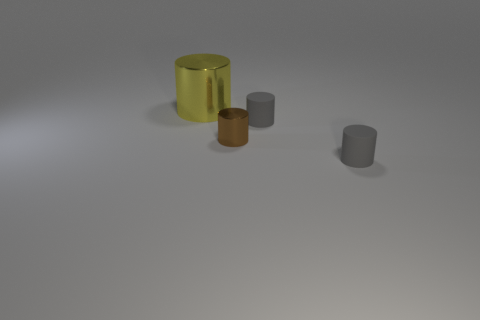Subtract all small cylinders. How many cylinders are left? 1 Add 3 small shiny objects. How many objects exist? 7 Subtract all brown cylinders. How many cylinders are left? 3 Add 1 tiny shiny cylinders. How many tiny shiny cylinders exist? 2 Subtract 0 red cylinders. How many objects are left? 4 Subtract 2 cylinders. How many cylinders are left? 2 Subtract all yellow cylinders. Subtract all blue blocks. How many cylinders are left? 3 Subtract all blue blocks. How many yellow cylinders are left? 1 Subtract all brown cylinders. Subtract all small gray objects. How many objects are left? 1 Add 3 small gray cylinders. How many small gray cylinders are left? 5 